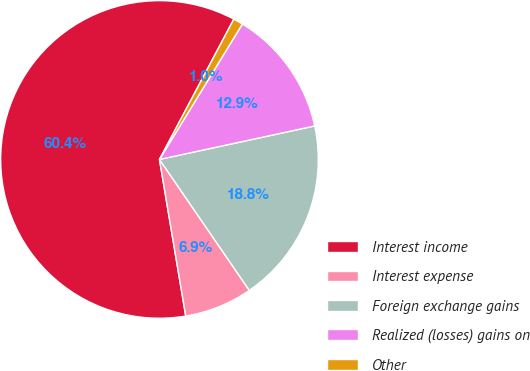Convert chart to OTSL. <chart><loc_0><loc_0><loc_500><loc_500><pie_chart><fcel>Interest income<fcel>Interest expense<fcel>Foreign exchange gains<fcel>Realized (losses) gains on<fcel>Other<nl><fcel>60.4%<fcel>6.93%<fcel>18.81%<fcel>12.87%<fcel>0.99%<nl></chart> 